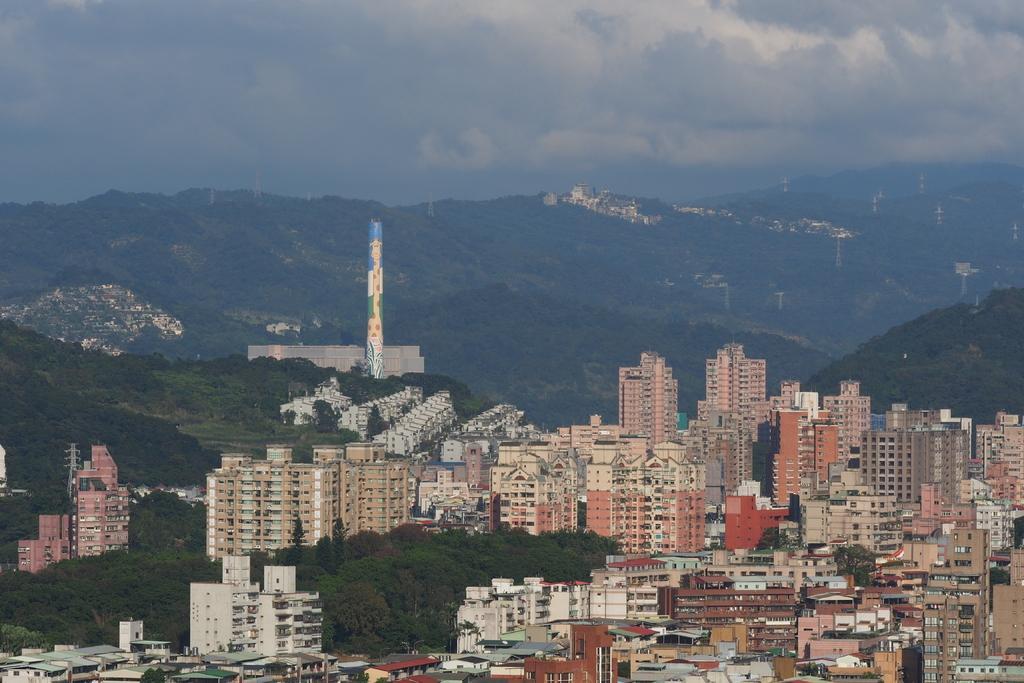Could you give a brief overview of what you see in this image? In this image there are buildings and trees. In the background there are hills and sky. 